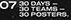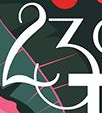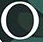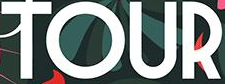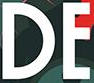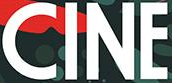Read the text from these images in sequence, separated by a semicolon. #; 23; °; TOUR; DE; CINE 